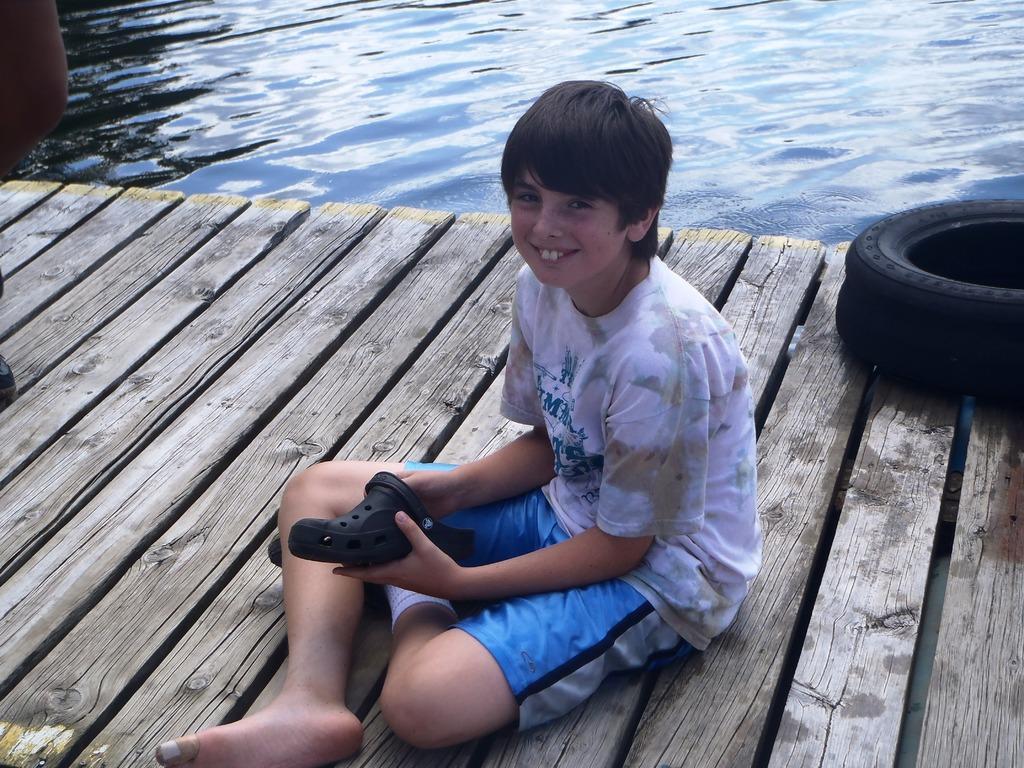How would you summarize this image in a sentence or two? In the image in the center we can see one boy is sitting on the wood floor. And we can see he is holding footwear and he is smiling,which we can see on his face. In the background we can see water and tire. 